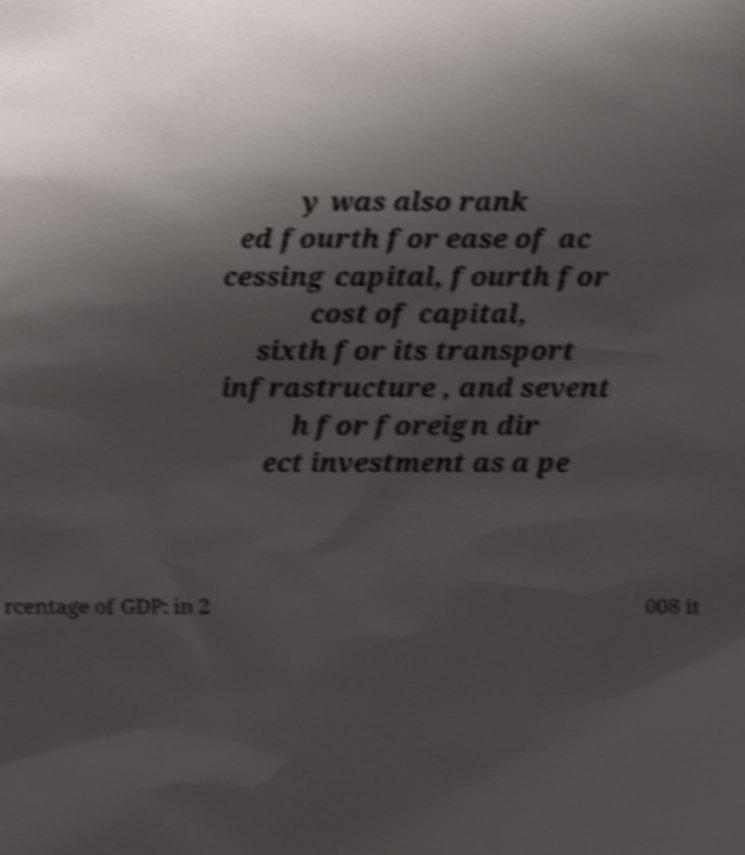Can you accurately transcribe the text from the provided image for me? y was also rank ed fourth for ease of ac cessing capital, fourth for cost of capital, sixth for its transport infrastructure , and sevent h for foreign dir ect investment as a pe rcentage of GDP: in 2 008 it 